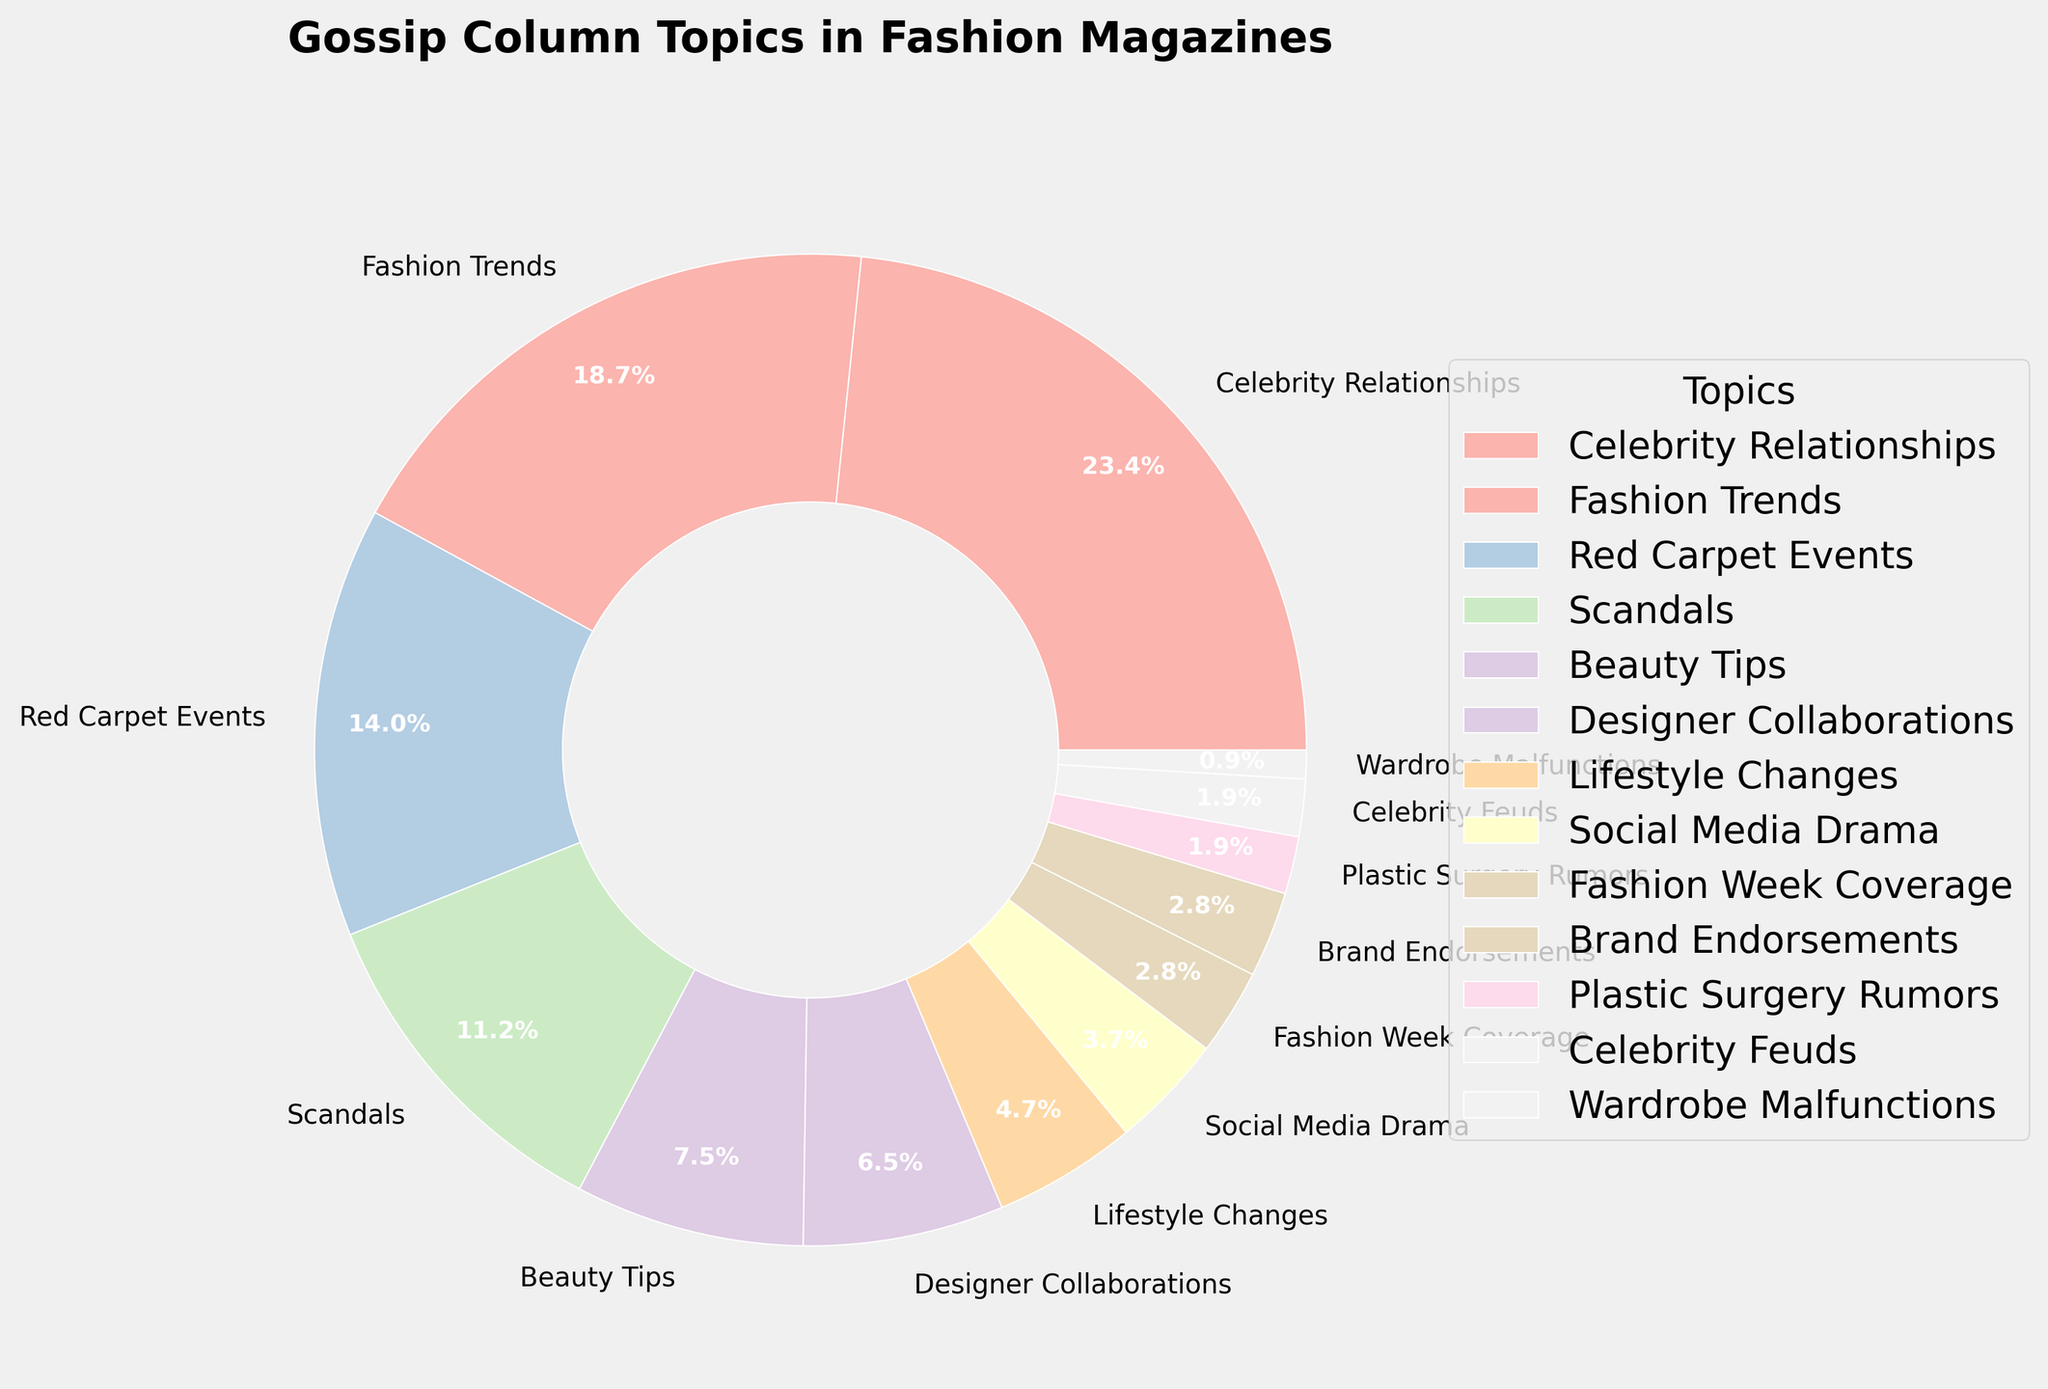What's the most talked-about topic in gossip columns? Look at the segment that occupies the largest portion of the pie chart to identify the most talked-about topic.
Answer: Celebrity Relationships Which topic has a lower percentage than Red Carpet Events but higher than Social Media Drama? Find the percentage of Red Carpet Events (15%) and Social Media Drama (4%). Identify the topic with a percentage in between these two values.
Answer: Scandals What's the combined percentage of Fashion Trends and Beauty Tips? Add the percentages of Fashion Trends (20%) and Beauty Tips (8%). 20 + 8 = 28
Answer: 28% Do Designer Collaborations have a greater or lesser percentage than Lifestyle Changes? Compare the percentage of Designer Collaborations (7%) with that of Lifestyle Changes (5%).
Answer: Greater Which two topics have the smallest percentages? Identify the two segments with the smallest portions in the pie chart, which should be the smallest numbers in the dataset (Plastic Surgery Rumors 2% and Wardrobe Malfunctions 1%).
Answer: Plastic Surgery Rumors and Wardrobe Malfunctions What’s the total percentage of topics related to celebrity gossip (Celebrity Relationships, Scandals, Plastic Surgery Rumors, and Celebrity Feuds)? Add the percentages of Celebrity Relationships (25%), Scandals (12%), Plastic Surgery Rumors (2%), and Celebrity Feuds (2%). 25 + 12 + 2 + 2 = 41
Answer: 41% Between Brand Endorsements and Fashion Week Coverage, which topic has a higher percentage? Compare the percentages of Brand Endorsements (3%) and Fashion Week Coverage (3%). Since they are equal, neither is higher.
Answer: They are equal Which topic is represented by a slightly larger segment: Lifestyle Changes or Social Media Drama? Compare the percentages of Lifestyle Changes (5%) and Social Media Drama (4%). Lifestyle Changes has a slightly larger segment.
Answer: Lifestyle Changes By how much does the percentage of Scandals exceed that of Fashion Week Coverage? Subtract the percentage of Fashion Week Coverage (3%) from that of Scandals (12%). 12 - 3 = 9
Answer: 9% What color is used most predominantly in the pie chart? Identify the most visually dominant color by seeing which large segments are colored most frequently. This answer could be the primary hues used for large shares like Celebrity Relationships or Fashion Trends.
Answer: Pastel Pink 